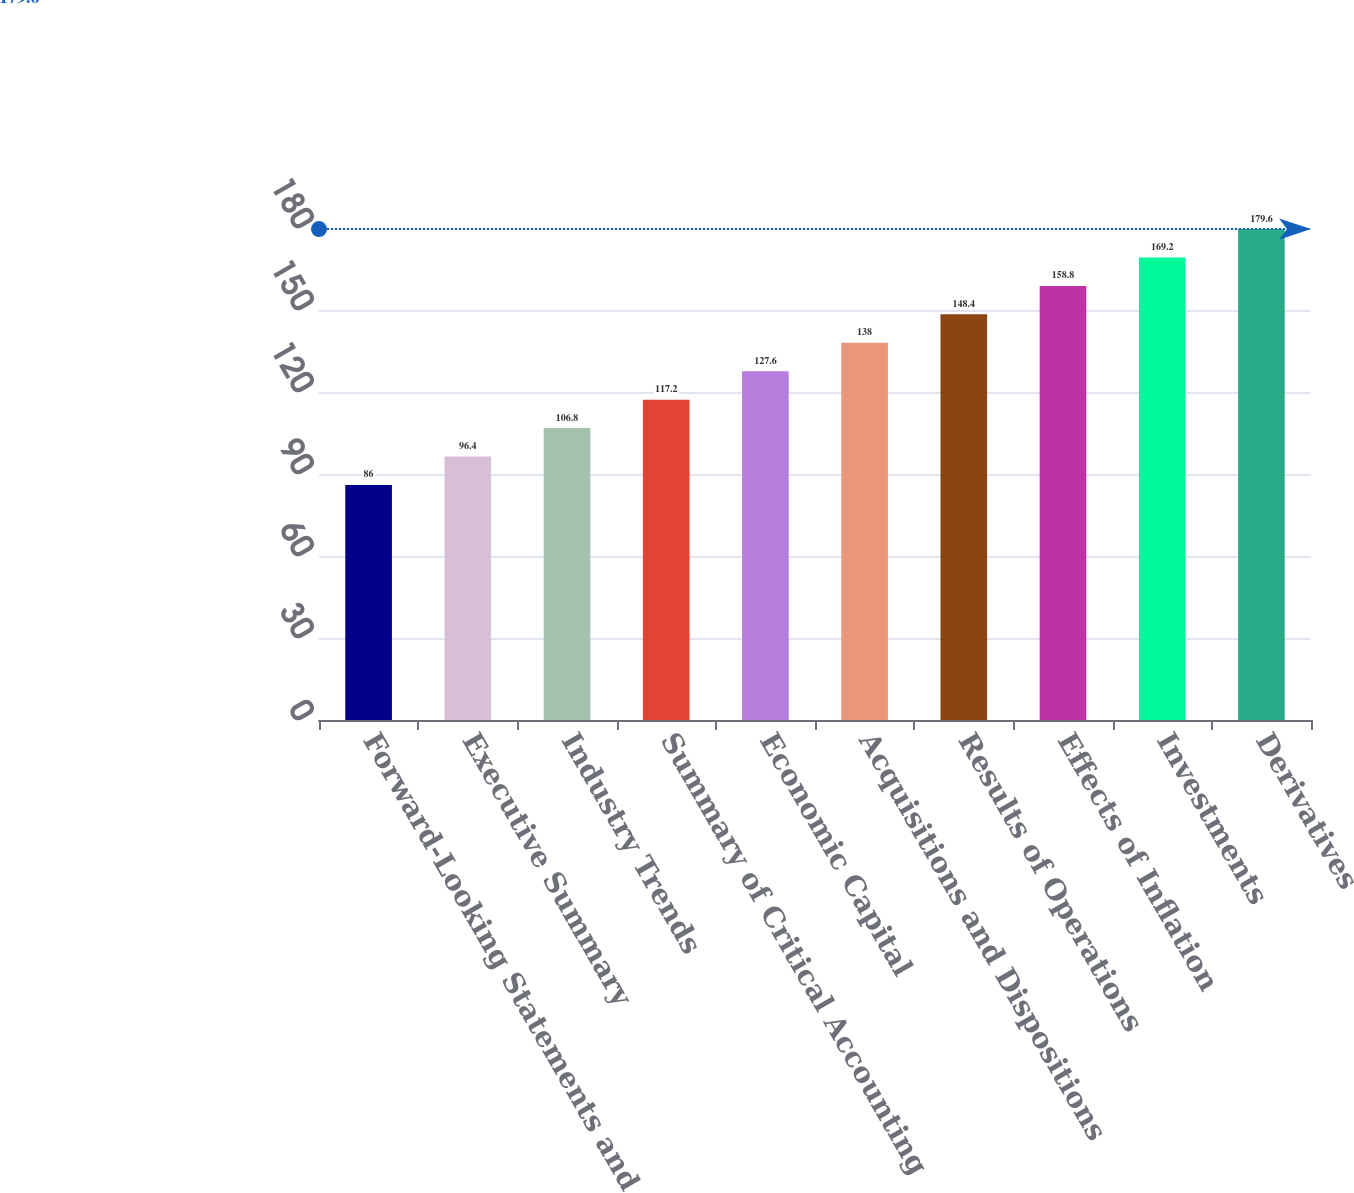<chart> <loc_0><loc_0><loc_500><loc_500><bar_chart><fcel>Forward-Looking Statements and<fcel>Executive Summary<fcel>Industry Trends<fcel>Summary of Critical Accounting<fcel>Economic Capital<fcel>Acquisitions and Dispositions<fcel>Results of Operations<fcel>Effects of Inflation<fcel>Investments<fcel>Derivatives<nl><fcel>86<fcel>96.4<fcel>106.8<fcel>117.2<fcel>127.6<fcel>138<fcel>148.4<fcel>158.8<fcel>169.2<fcel>179.6<nl></chart> 